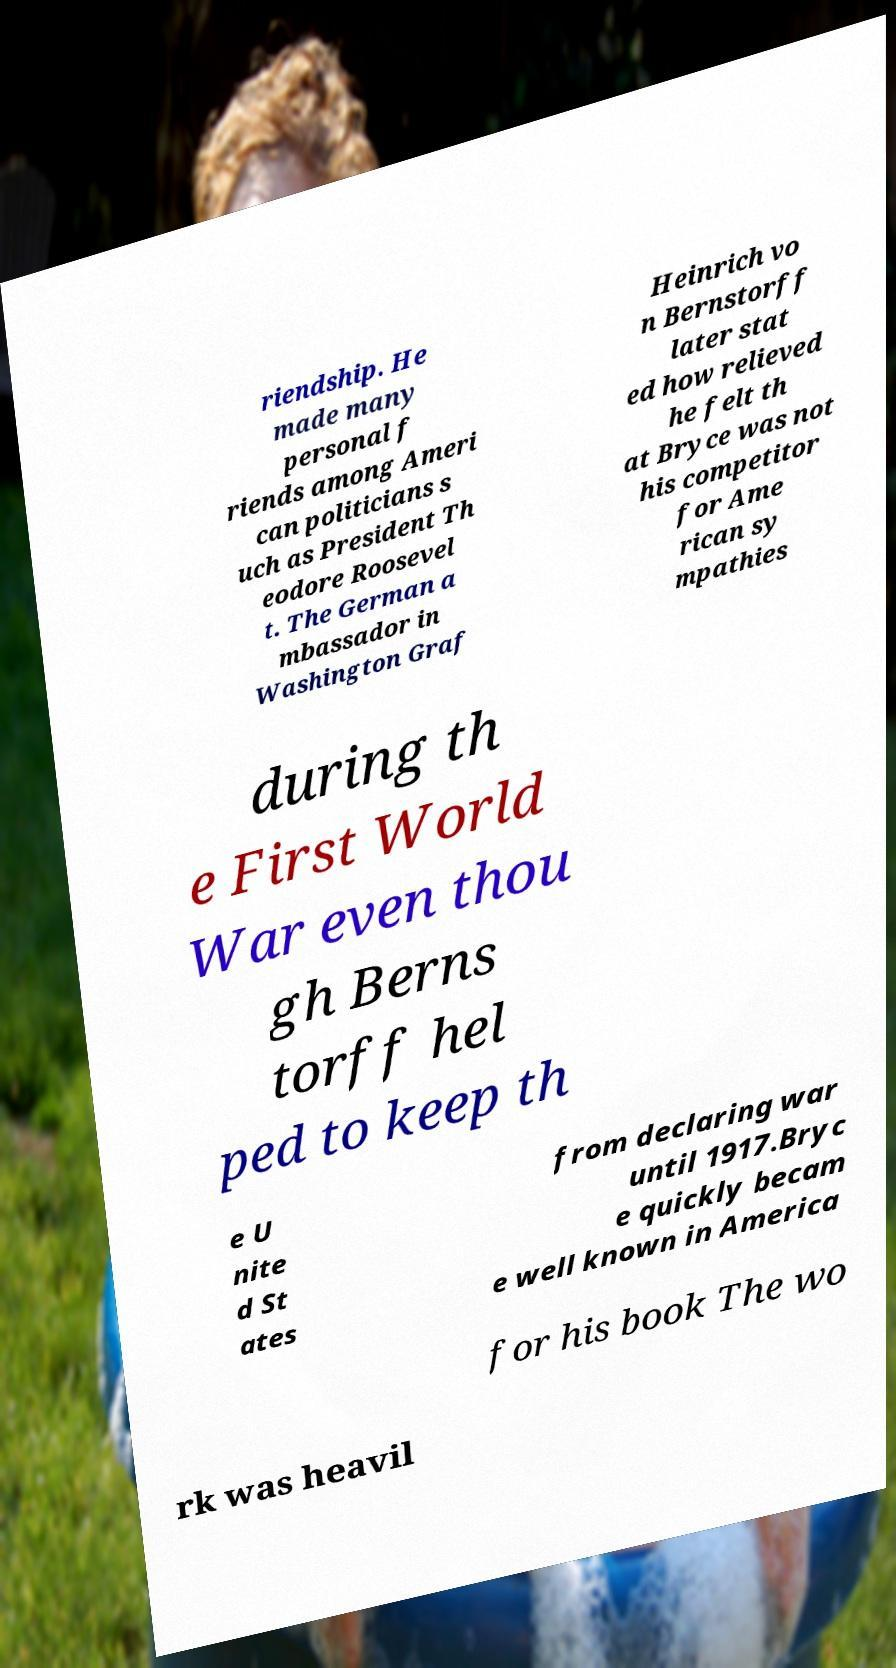Could you assist in decoding the text presented in this image and type it out clearly? riendship. He made many personal f riends among Ameri can politicians s uch as President Th eodore Roosevel t. The German a mbassador in Washington Graf Heinrich vo n Bernstorff later stat ed how relieved he felt th at Bryce was not his competitor for Ame rican sy mpathies during th e First World War even thou gh Berns torff hel ped to keep th e U nite d St ates from declaring war until 1917.Bryc e quickly becam e well known in America for his book The wo rk was heavil 